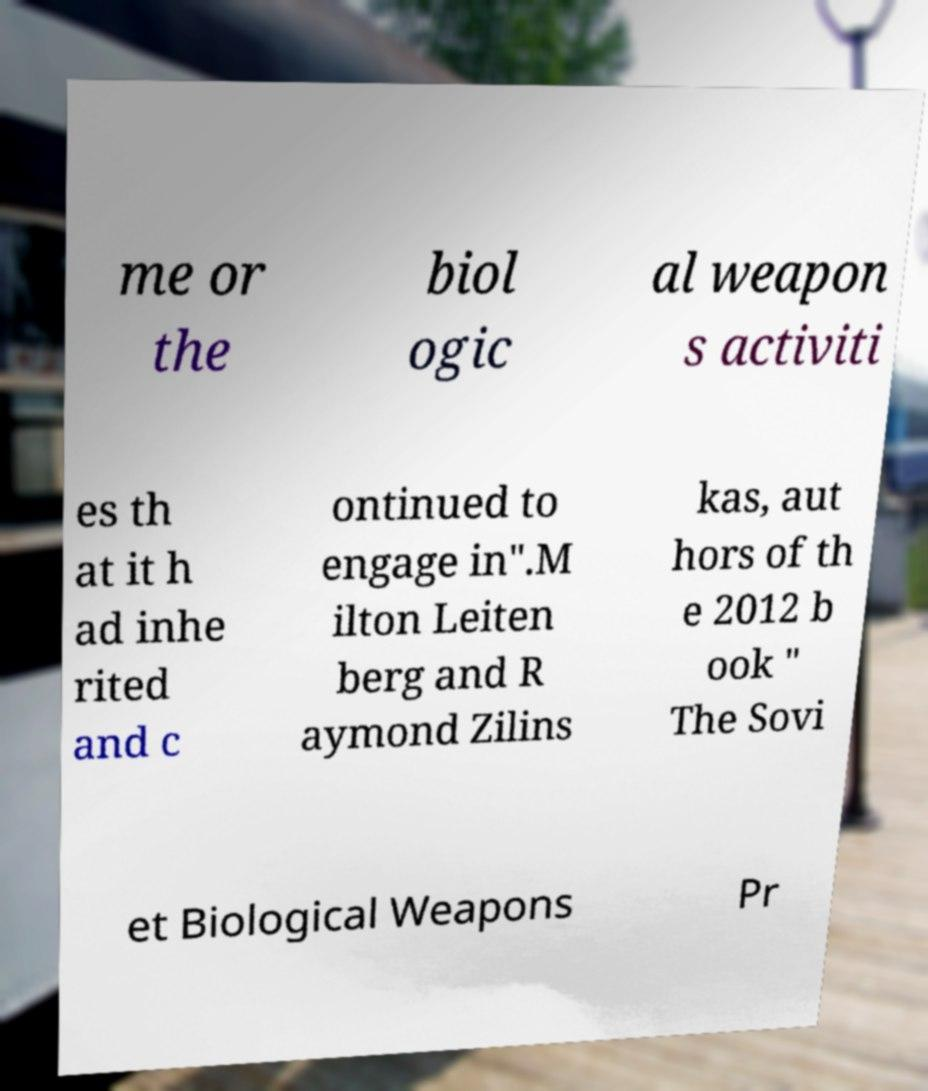Could you assist in decoding the text presented in this image and type it out clearly? me or the biol ogic al weapon s activiti es th at it h ad inhe rited and c ontinued to engage in".M ilton Leiten berg and R aymond Zilins kas, aut hors of th e 2012 b ook " The Sovi et Biological Weapons Pr 